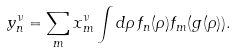<formula> <loc_0><loc_0><loc_500><loc_500>y ^ { \nu } _ { n } = \sum _ { m } x ^ { \nu } _ { m } \int d \rho \, f _ { n } ( \rho ) f _ { m } ( g ( \rho ) ) .</formula> 